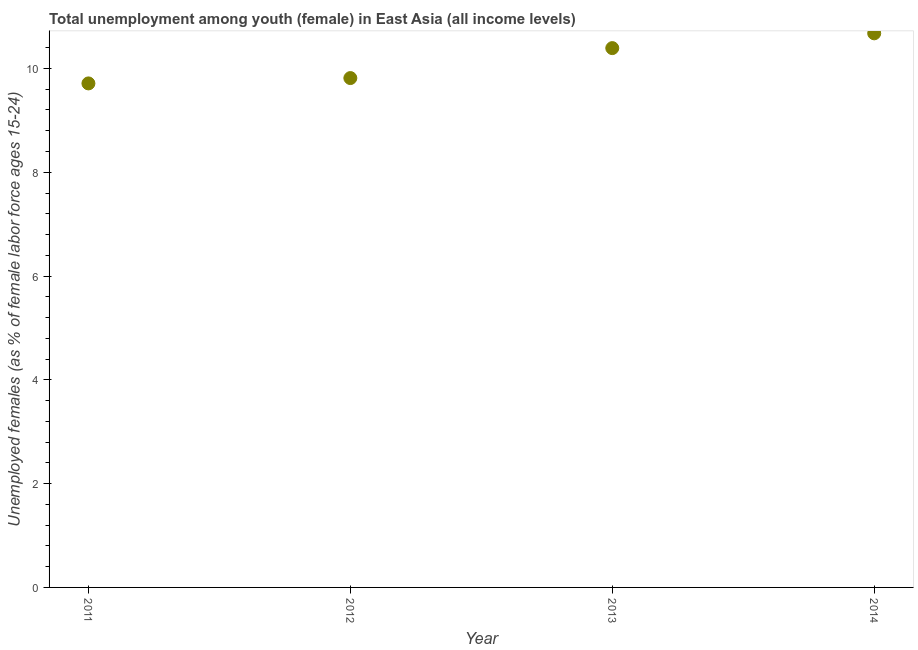What is the unemployed female youth population in 2013?
Your answer should be very brief. 10.39. Across all years, what is the maximum unemployed female youth population?
Your answer should be compact. 10.68. Across all years, what is the minimum unemployed female youth population?
Provide a succinct answer. 9.71. In which year was the unemployed female youth population maximum?
Provide a short and direct response. 2014. What is the sum of the unemployed female youth population?
Offer a terse response. 40.6. What is the difference between the unemployed female youth population in 2013 and 2014?
Offer a very short reply. -0.28. What is the average unemployed female youth population per year?
Your answer should be compact. 10.15. What is the median unemployed female youth population?
Keep it short and to the point. 10.1. What is the ratio of the unemployed female youth population in 2013 to that in 2014?
Ensure brevity in your answer.  0.97. Is the unemployed female youth population in 2011 less than that in 2014?
Offer a very short reply. Yes. Is the difference between the unemployed female youth population in 2013 and 2014 greater than the difference between any two years?
Provide a short and direct response. No. What is the difference between the highest and the second highest unemployed female youth population?
Offer a terse response. 0.28. What is the difference between the highest and the lowest unemployed female youth population?
Provide a succinct answer. 0.97. Are the values on the major ticks of Y-axis written in scientific E-notation?
Keep it short and to the point. No. Does the graph contain any zero values?
Your answer should be very brief. No. What is the title of the graph?
Provide a short and direct response. Total unemployment among youth (female) in East Asia (all income levels). What is the label or title of the X-axis?
Offer a terse response. Year. What is the label or title of the Y-axis?
Provide a succinct answer. Unemployed females (as % of female labor force ages 15-24). What is the Unemployed females (as % of female labor force ages 15-24) in 2011?
Your answer should be compact. 9.71. What is the Unemployed females (as % of female labor force ages 15-24) in 2012?
Offer a terse response. 9.81. What is the Unemployed females (as % of female labor force ages 15-24) in 2013?
Ensure brevity in your answer.  10.39. What is the Unemployed females (as % of female labor force ages 15-24) in 2014?
Your response must be concise. 10.68. What is the difference between the Unemployed females (as % of female labor force ages 15-24) in 2011 and 2012?
Keep it short and to the point. -0.1. What is the difference between the Unemployed females (as % of female labor force ages 15-24) in 2011 and 2013?
Make the answer very short. -0.68. What is the difference between the Unemployed females (as % of female labor force ages 15-24) in 2011 and 2014?
Your answer should be very brief. -0.97. What is the difference between the Unemployed females (as % of female labor force ages 15-24) in 2012 and 2013?
Your answer should be very brief. -0.58. What is the difference between the Unemployed females (as % of female labor force ages 15-24) in 2012 and 2014?
Provide a succinct answer. -0.86. What is the difference between the Unemployed females (as % of female labor force ages 15-24) in 2013 and 2014?
Give a very brief answer. -0.28. What is the ratio of the Unemployed females (as % of female labor force ages 15-24) in 2011 to that in 2012?
Ensure brevity in your answer.  0.99. What is the ratio of the Unemployed females (as % of female labor force ages 15-24) in 2011 to that in 2013?
Provide a short and direct response. 0.94. What is the ratio of the Unemployed females (as % of female labor force ages 15-24) in 2011 to that in 2014?
Make the answer very short. 0.91. What is the ratio of the Unemployed females (as % of female labor force ages 15-24) in 2012 to that in 2013?
Keep it short and to the point. 0.94. What is the ratio of the Unemployed females (as % of female labor force ages 15-24) in 2012 to that in 2014?
Keep it short and to the point. 0.92. 